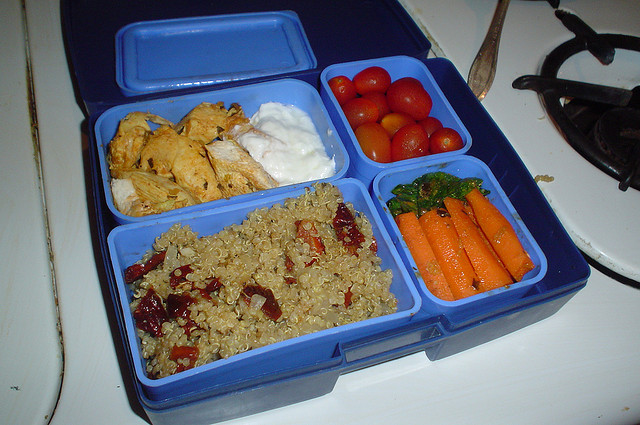<image>What utensil is in the right section of the lunch box? It is not clear whether there is a utensil in the right section of the lunch box or not. It could be a fork, knife, or spoon. What utensil is in the right section of the lunch box? I don't know what utensil is in the right section of the lunch box. It can be a fork, a knife, a spoon or none. 